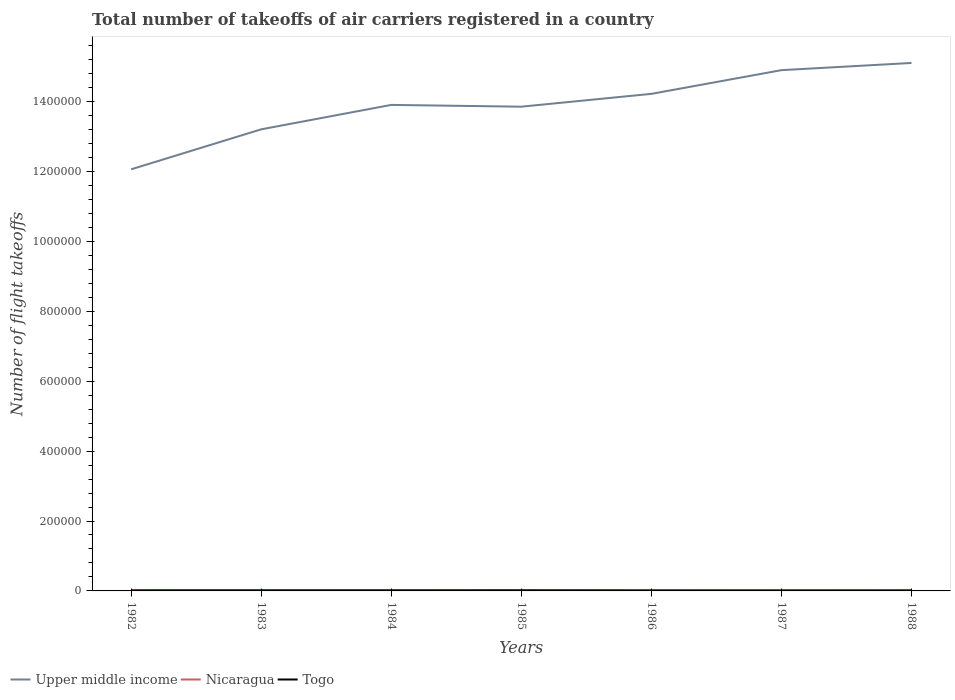How many different coloured lines are there?
Ensure brevity in your answer.  3. Does the line corresponding to Nicaragua intersect with the line corresponding to Togo?
Your response must be concise. No. Is the number of lines equal to the number of legend labels?
Your answer should be compact. Yes. Across all years, what is the maximum total number of flight takeoffs in Togo?
Provide a short and direct response. 1000. What is the total total number of flight takeoffs in Upper middle income in the graph?
Make the answer very short. -1.04e+05. What is the difference between the highest and the second highest total number of flight takeoffs in Upper middle income?
Offer a very short reply. 3.04e+05. How many lines are there?
Make the answer very short. 3. What is the difference between two consecutive major ticks on the Y-axis?
Make the answer very short. 2.00e+05. Are the values on the major ticks of Y-axis written in scientific E-notation?
Your response must be concise. No. How many legend labels are there?
Your answer should be very brief. 3. What is the title of the graph?
Your answer should be very brief. Total number of takeoffs of air carriers registered in a country. What is the label or title of the X-axis?
Make the answer very short. Years. What is the label or title of the Y-axis?
Give a very brief answer. Number of flight takeoffs. What is the Number of flight takeoffs of Upper middle income in 1982?
Provide a succinct answer. 1.21e+06. What is the Number of flight takeoffs in Nicaragua in 1982?
Ensure brevity in your answer.  1800. What is the Number of flight takeoffs in Togo in 1982?
Offer a very short reply. 1400. What is the Number of flight takeoffs in Upper middle income in 1983?
Your answer should be very brief. 1.32e+06. What is the Number of flight takeoffs in Nicaragua in 1983?
Ensure brevity in your answer.  1900. What is the Number of flight takeoffs of Togo in 1983?
Provide a succinct answer. 1400. What is the Number of flight takeoffs in Upper middle income in 1984?
Ensure brevity in your answer.  1.39e+06. What is the Number of flight takeoffs in Nicaragua in 1984?
Provide a succinct answer. 2200. What is the Number of flight takeoffs of Togo in 1984?
Your response must be concise. 1300. What is the Number of flight takeoffs of Upper middle income in 1985?
Provide a succinct answer. 1.39e+06. What is the Number of flight takeoffs of Nicaragua in 1985?
Provide a succinct answer. 2300. What is the Number of flight takeoffs in Togo in 1985?
Provide a succinct answer. 1400. What is the Number of flight takeoffs of Upper middle income in 1986?
Make the answer very short. 1.42e+06. What is the Number of flight takeoffs of Togo in 1986?
Offer a terse response. 1100. What is the Number of flight takeoffs in Upper middle income in 1987?
Your answer should be compact. 1.49e+06. What is the Number of flight takeoffs in Upper middle income in 1988?
Make the answer very short. 1.51e+06. What is the Number of flight takeoffs of Togo in 1988?
Your response must be concise. 1100. Across all years, what is the maximum Number of flight takeoffs of Upper middle income?
Offer a terse response. 1.51e+06. Across all years, what is the maximum Number of flight takeoffs in Nicaragua?
Your answer should be very brief. 2300. Across all years, what is the maximum Number of flight takeoffs in Togo?
Ensure brevity in your answer.  1400. Across all years, what is the minimum Number of flight takeoffs in Upper middle income?
Offer a terse response. 1.21e+06. Across all years, what is the minimum Number of flight takeoffs in Nicaragua?
Your answer should be very brief. 1800. Across all years, what is the minimum Number of flight takeoffs of Togo?
Provide a succinct answer. 1000. What is the total Number of flight takeoffs of Upper middle income in the graph?
Your response must be concise. 9.73e+06. What is the total Number of flight takeoffs of Nicaragua in the graph?
Provide a short and direct response. 1.42e+04. What is the total Number of flight takeoffs of Togo in the graph?
Ensure brevity in your answer.  8700. What is the difference between the Number of flight takeoffs of Upper middle income in 1982 and that in 1983?
Offer a terse response. -1.14e+05. What is the difference between the Number of flight takeoffs in Nicaragua in 1982 and that in 1983?
Your answer should be very brief. -100. What is the difference between the Number of flight takeoffs of Upper middle income in 1982 and that in 1984?
Ensure brevity in your answer.  -1.84e+05. What is the difference between the Number of flight takeoffs of Nicaragua in 1982 and that in 1984?
Your answer should be very brief. -400. What is the difference between the Number of flight takeoffs of Togo in 1982 and that in 1984?
Provide a short and direct response. 100. What is the difference between the Number of flight takeoffs in Upper middle income in 1982 and that in 1985?
Provide a short and direct response. -1.79e+05. What is the difference between the Number of flight takeoffs of Nicaragua in 1982 and that in 1985?
Your answer should be compact. -500. What is the difference between the Number of flight takeoffs in Upper middle income in 1982 and that in 1986?
Give a very brief answer. -2.16e+05. What is the difference between the Number of flight takeoffs of Nicaragua in 1982 and that in 1986?
Your answer should be compact. -200. What is the difference between the Number of flight takeoffs of Togo in 1982 and that in 1986?
Make the answer very short. 300. What is the difference between the Number of flight takeoffs of Upper middle income in 1982 and that in 1987?
Keep it short and to the point. -2.84e+05. What is the difference between the Number of flight takeoffs in Nicaragua in 1982 and that in 1987?
Offer a very short reply. -200. What is the difference between the Number of flight takeoffs of Togo in 1982 and that in 1987?
Ensure brevity in your answer.  400. What is the difference between the Number of flight takeoffs of Upper middle income in 1982 and that in 1988?
Your answer should be very brief. -3.04e+05. What is the difference between the Number of flight takeoffs of Nicaragua in 1982 and that in 1988?
Offer a very short reply. -200. What is the difference between the Number of flight takeoffs in Togo in 1982 and that in 1988?
Make the answer very short. 300. What is the difference between the Number of flight takeoffs in Upper middle income in 1983 and that in 1984?
Your response must be concise. -6.99e+04. What is the difference between the Number of flight takeoffs of Nicaragua in 1983 and that in 1984?
Make the answer very short. -300. What is the difference between the Number of flight takeoffs in Togo in 1983 and that in 1984?
Make the answer very short. 100. What is the difference between the Number of flight takeoffs in Upper middle income in 1983 and that in 1985?
Your answer should be very brief. -6.48e+04. What is the difference between the Number of flight takeoffs of Nicaragua in 1983 and that in 1985?
Keep it short and to the point. -400. What is the difference between the Number of flight takeoffs of Upper middle income in 1983 and that in 1986?
Keep it short and to the point. -1.02e+05. What is the difference between the Number of flight takeoffs of Nicaragua in 1983 and that in 1986?
Your response must be concise. -100. What is the difference between the Number of flight takeoffs of Togo in 1983 and that in 1986?
Offer a very short reply. 300. What is the difference between the Number of flight takeoffs of Upper middle income in 1983 and that in 1987?
Provide a succinct answer. -1.69e+05. What is the difference between the Number of flight takeoffs of Nicaragua in 1983 and that in 1987?
Keep it short and to the point. -100. What is the difference between the Number of flight takeoffs of Upper middle income in 1983 and that in 1988?
Offer a very short reply. -1.90e+05. What is the difference between the Number of flight takeoffs in Nicaragua in 1983 and that in 1988?
Keep it short and to the point. -100. What is the difference between the Number of flight takeoffs in Togo in 1983 and that in 1988?
Offer a very short reply. 300. What is the difference between the Number of flight takeoffs of Upper middle income in 1984 and that in 1985?
Your answer should be compact. 5100. What is the difference between the Number of flight takeoffs of Nicaragua in 1984 and that in 1985?
Make the answer very short. -100. What is the difference between the Number of flight takeoffs of Togo in 1984 and that in 1985?
Provide a succinct answer. -100. What is the difference between the Number of flight takeoffs in Upper middle income in 1984 and that in 1986?
Your answer should be very brief. -3.16e+04. What is the difference between the Number of flight takeoffs in Upper middle income in 1984 and that in 1987?
Offer a very short reply. -9.94e+04. What is the difference between the Number of flight takeoffs in Togo in 1984 and that in 1987?
Make the answer very short. 300. What is the difference between the Number of flight takeoffs of Upper middle income in 1984 and that in 1988?
Give a very brief answer. -1.20e+05. What is the difference between the Number of flight takeoffs of Togo in 1984 and that in 1988?
Your answer should be very brief. 200. What is the difference between the Number of flight takeoffs of Upper middle income in 1985 and that in 1986?
Your response must be concise. -3.67e+04. What is the difference between the Number of flight takeoffs of Nicaragua in 1985 and that in 1986?
Offer a terse response. 300. What is the difference between the Number of flight takeoffs in Togo in 1985 and that in 1986?
Your answer should be very brief. 300. What is the difference between the Number of flight takeoffs in Upper middle income in 1985 and that in 1987?
Your answer should be very brief. -1.04e+05. What is the difference between the Number of flight takeoffs of Nicaragua in 1985 and that in 1987?
Keep it short and to the point. 300. What is the difference between the Number of flight takeoffs of Upper middle income in 1985 and that in 1988?
Make the answer very short. -1.25e+05. What is the difference between the Number of flight takeoffs in Nicaragua in 1985 and that in 1988?
Offer a very short reply. 300. What is the difference between the Number of flight takeoffs of Togo in 1985 and that in 1988?
Your response must be concise. 300. What is the difference between the Number of flight takeoffs in Upper middle income in 1986 and that in 1987?
Offer a terse response. -6.78e+04. What is the difference between the Number of flight takeoffs of Nicaragua in 1986 and that in 1987?
Make the answer very short. 0. What is the difference between the Number of flight takeoffs of Upper middle income in 1986 and that in 1988?
Offer a terse response. -8.84e+04. What is the difference between the Number of flight takeoffs in Togo in 1986 and that in 1988?
Give a very brief answer. 0. What is the difference between the Number of flight takeoffs of Upper middle income in 1987 and that in 1988?
Give a very brief answer. -2.06e+04. What is the difference between the Number of flight takeoffs of Togo in 1987 and that in 1988?
Give a very brief answer. -100. What is the difference between the Number of flight takeoffs of Upper middle income in 1982 and the Number of flight takeoffs of Nicaragua in 1983?
Ensure brevity in your answer.  1.20e+06. What is the difference between the Number of flight takeoffs in Upper middle income in 1982 and the Number of flight takeoffs in Togo in 1983?
Give a very brief answer. 1.20e+06. What is the difference between the Number of flight takeoffs of Nicaragua in 1982 and the Number of flight takeoffs of Togo in 1983?
Ensure brevity in your answer.  400. What is the difference between the Number of flight takeoffs in Upper middle income in 1982 and the Number of flight takeoffs in Nicaragua in 1984?
Ensure brevity in your answer.  1.20e+06. What is the difference between the Number of flight takeoffs in Upper middle income in 1982 and the Number of flight takeoffs in Togo in 1984?
Make the answer very short. 1.20e+06. What is the difference between the Number of flight takeoffs of Upper middle income in 1982 and the Number of flight takeoffs of Nicaragua in 1985?
Offer a terse response. 1.20e+06. What is the difference between the Number of flight takeoffs of Upper middle income in 1982 and the Number of flight takeoffs of Togo in 1985?
Provide a short and direct response. 1.20e+06. What is the difference between the Number of flight takeoffs in Nicaragua in 1982 and the Number of flight takeoffs in Togo in 1985?
Provide a short and direct response. 400. What is the difference between the Number of flight takeoffs of Upper middle income in 1982 and the Number of flight takeoffs of Nicaragua in 1986?
Your answer should be compact. 1.20e+06. What is the difference between the Number of flight takeoffs in Upper middle income in 1982 and the Number of flight takeoffs in Togo in 1986?
Provide a short and direct response. 1.21e+06. What is the difference between the Number of flight takeoffs in Nicaragua in 1982 and the Number of flight takeoffs in Togo in 1986?
Give a very brief answer. 700. What is the difference between the Number of flight takeoffs of Upper middle income in 1982 and the Number of flight takeoffs of Nicaragua in 1987?
Give a very brief answer. 1.20e+06. What is the difference between the Number of flight takeoffs of Upper middle income in 1982 and the Number of flight takeoffs of Togo in 1987?
Your answer should be very brief. 1.21e+06. What is the difference between the Number of flight takeoffs of Nicaragua in 1982 and the Number of flight takeoffs of Togo in 1987?
Make the answer very short. 800. What is the difference between the Number of flight takeoffs in Upper middle income in 1982 and the Number of flight takeoffs in Nicaragua in 1988?
Keep it short and to the point. 1.20e+06. What is the difference between the Number of flight takeoffs in Upper middle income in 1982 and the Number of flight takeoffs in Togo in 1988?
Keep it short and to the point. 1.21e+06. What is the difference between the Number of flight takeoffs of Nicaragua in 1982 and the Number of flight takeoffs of Togo in 1988?
Give a very brief answer. 700. What is the difference between the Number of flight takeoffs in Upper middle income in 1983 and the Number of flight takeoffs in Nicaragua in 1984?
Provide a succinct answer. 1.32e+06. What is the difference between the Number of flight takeoffs of Upper middle income in 1983 and the Number of flight takeoffs of Togo in 1984?
Provide a short and direct response. 1.32e+06. What is the difference between the Number of flight takeoffs of Nicaragua in 1983 and the Number of flight takeoffs of Togo in 1984?
Give a very brief answer. 600. What is the difference between the Number of flight takeoffs of Upper middle income in 1983 and the Number of flight takeoffs of Nicaragua in 1985?
Your answer should be very brief. 1.32e+06. What is the difference between the Number of flight takeoffs of Upper middle income in 1983 and the Number of flight takeoffs of Togo in 1985?
Ensure brevity in your answer.  1.32e+06. What is the difference between the Number of flight takeoffs in Nicaragua in 1983 and the Number of flight takeoffs in Togo in 1985?
Ensure brevity in your answer.  500. What is the difference between the Number of flight takeoffs in Upper middle income in 1983 and the Number of flight takeoffs in Nicaragua in 1986?
Give a very brief answer. 1.32e+06. What is the difference between the Number of flight takeoffs in Upper middle income in 1983 and the Number of flight takeoffs in Togo in 1986?
Provide a short and direct response. 1.32e+06. What is the difference between the Number of flight takeoffs of Nicaragua in 1983 and the Number of flight takeoffs of Togo in 1986?
Offer a very short reply. 800. What is the difference between the Number of flight takeoffs in Upper middle income in 1983 and the Number of flight takeoffs in Nicaragua in 1987?
Ensure brevity in your answer.  1.32e+06. What is the difference between the Number of flight takeoffs of Upper middle income in 1983 and the Number of flight takeoffs of Togo in 1987?
Offer a terse response. 1.32e+06. What is the difference between the Number of flight takeoffs of Nicaragua in 1983 and the Number of flight takeoffs of Togo in 1987?
Your answer should be very brief. 900. What is the difference between the Number of flight takeoffs in Upper middle income in 1983 and the Number of flight takeoffs in Nicaragua in 1988?
Provide a short and direct response. 1.32e+06. What is the difference between the Number of flight takeoffs of Upper middle income in 1983 and the Number of flight takeoffs of Togo in 1988?
Provide a succinct answer. 1.32e+06. What is the difference between the Number of flight takeoffs in Nicaragua in 1983 and the Number of flight takeoffs in Togo in 1988?
Make the answer very short. 800. What is the difference between the Number of flight takeoffs of Upper middle income in 1984 and the Number of flight takeoffs of Nicaragua in 1985?
Make the answer very short. 1.39e+06. What is the difference between the Number of flight takeoffs of Upper middle income in 1984 and the Number of flight takeoffs of Togo in 1985?
Ensure brevity in your answer.  1.39e+06. What is the difference between the Number of flight takeoffs of Nicaragua in 1984 and the Number of flight takeoffs of Togo in 1985?
Offer a terse response. 800. What is the difference between the Number of flight takeoffs in Upper middle income in 1984 and the Number of flight takeoffs in Nicaragua in 1986?
Your answer should be very brief. 1.39e+06. What is the difference between the Number of flight takeoffs of Upper middle income in 1984 and the Number of flight takeoffs of Togo in 1986?
Your response must be concise. 1.39e+06. What is the difference between the Number of flight takeoffs in Nicaragua in 1984 and the Number of flight takeoffs in Togo in 1986?
Offer a terse response. 1100. What is the difference between the Number of flight takeoffs of Upper middle income in 1984 and the Number of flight takeoffs of Nicaragua in 1987?
Offer a terse response. 1.39e+06. What is the difference between the Number of flight takeoffs in Upper middle income in 1984 and the Number of flight takeoffs in Togo in 1987?
Give a very brief answer. 1.39e+06. What is the difference between the Number of flight takeoffs in Nicaragua in 1984 and the Number of flight takeoffs in Togo in 1987?
Make the answer very short. 1200. What is the difference between the Number of flight takeoffs in Upper middle income in 1984 and the Number of flight takeoffs in Nicaragua in 1988?
Give a very brief answer. 1.39e+06. What is the difference between the Number of flight takeoffs in Upper middle income in 1984 and the Number of flight takeoffs in Togo in 1988?
Your answer should be compact. 1.39e+06. What is the difference between the Number of flight takeoffs of Nicaragua in 1984 and the Number of flight takeoffs of Togo in 1988?
Offer a terse response. 1100. What is the difference between the Number of flight takeoffs of Upper middle income in 1985 and the Number of flight takeoffs of Nicaragua in 1986?
Provide a short and direct response. 1.38e+06. What is the difference between the Number of flight takeoffs of Upper middle income in 1985 and the Number of flight takeoffs of Togo in 1986?
Make the answer very short. 1.38e+06. What is the difference between the Number of flight takeoffs in Nicaragua in 1985 and the Number of flight takeoffs in Togo in 1986?
Offer a terse response. 1200. What is the difference between the Number of flight takeoffs of Upper middle income in 1985 and the Number of flight takeoffs of Nicaragua in 1987?
Your answer should be compact. 1.38e+06. What is the difference between the Number of flight takeoffs in Upper middle income in 1985 and the Number of flight takeoffs in Togo in 1987?
Give a very brief answer. 1.38e+06. What is the difference between the Number of flight takeoffs of Nicaragua in 1985 and the Number of flight takeoffs of Togo in 1987?
Provide a succinct answer. 1300. What is the difference between the Number of flight takeoffs of Upper middle income in 1985 and the Number of flight takeoffs of Nicaragua in 1988?
Your response must be concise. 1.38e+06. What is the difference between the Number of flight takeoffs in Upper middle income in 1985 and the Number of flight takeoffs in Togo in 1988?
Ensure brevity in your answer.  1.38e+06. What is the difference between the Number of flight takeoffs of Nicaragua in 1985 and the Number of flight takeoffs of Togo in 1988?
Offer a terse response. 1200. What is the difference between the Number of flight takeoffs of Upper middle income in 1986 and the Number of flight takeoffs of Nicaragua in 1987?
Provide a succinct answer. 1.42e+06. What is the difference between the Number of flight takeoffs of Upper middle income in 1986 and the Number of flight takeoffs of Togo in 1987?
Your answer should be very brief. 1.42e+06. What is the difference between the Number of flight takeoffs in Upper middle income in 1986 and the Number of flight takeoffs in Nicaragua in 1988?
Offer a terse response. 1.42e+06. What is the difference between the Number of flight takeoffs of Upper middle income in 1986 and the Number of flight takeoffs of Togo in 1988?
Give a very brief answer. 1.42e+06. What is the difference between the Number of flight takeoffs in Nicaragua in 1986 and the Number of flight takeoffs in Togo in 1988?
Ensure brevity in your answer.  900. What is the difference between the Number of flight takeoffs of Upper middle income in 1987 and the Number of flight takeoffs of Nicaragua in 1988?
Ensure brevity in your answer.  1.49e+06. What is the difference between the Number of flight takeoffs in Upper middle income in 1987 and the Number of flight takeoffs in Togo in 1988?
Provide a short and direct response. 1.49e+06. What is the difference between the Number of flight takeoffs of Nicaragua in 1987 and the Number of flight takeoffs of Togo in 1988?
Your answer should be very brief. 900. What is the average Number of flight takeoffs in Upper middle income per year?
Offer a very short reply. 1.39e+06. What is the average Number of flight takeoffs of Nicaragua per year?
Provide a short and direct response. 2028.57. What is the average Number of flight takeoffs of Togo per year?
Your answer should be compact. 1242.86. In the year 1982, what is the difference between the Number of flight takeoffs of Upper middle income and Number of flight takeoffs of Nicaragua?
Your response must be concise. 1.20e+06. In the year 1982, what is the difference between the Number of flight takeoffs of Upper middle income and Number of flight takeoffs of Togo?
Make the answer very short. 1.20e+06. In the year 1982, what is the difference between the Number of flight takeoffs of Nicaragua and Number of flight takeoffs of Togo?
Your answer should be very brief. 400. In the year 1983, what is the difference between the Number of flight takeoffs in Upper middle income and Number of flight takeoffs in Nicaragua?
Provide a short and direct response. 1.32e+06. In the year 1983, what is the difference between the Number of flight takeoffs of Upper middle income and Number of flight takeoffs of Togo?
Offer a terse response. 1.32e+06. In the year 1983, what is the difference between the Number of flight takeoffs of Nicaragua and Number of flight takeoffs of Togo?
Offer a very short reply. 500. In the year 1984, what is the difference between the Number of flight takeoffs of Upper middle income and Number of flight takeoffs of Nicaragua?
Give a very brief answer. 1.39e+06. In the year 1984, what is the difference between the Number of flight takeoffs in Upper middle income and Number of flight takeoffs in Togo?
Offer a terse response. 1.39e+06. In the year 1984, what is the difference between the Number of flight takeoffs of Nicaragua and Number of flight takeoffs of Togo?
Ensure brevity in your answer.  900. In the year 1985, what is the difference between the Number of flight takeoffs in Upper middle income and Number of flight takeoffs in Nicaragua?
Offer a very short reply. 1.38e+06. In the year 1985, what is the difference between the Number of flight takeoffs in Upper middle income and Number of flight takeoffs in Togo?
Your answer should be compact. 1.38e+06. In the year 1985, what is the difference between the Number of flight takeoffs of Nicaragua and Number of flight takeoffs of Togo?
Give a very brief answer. 900. In the year 1986, what is the difference between the Number of flight takeoffs of Upper middle income and Number of flight takeoffs of Nicaragua?
Your answer should be compact. 1.42e+06. In the year 1986, what is the difference between the Number of flight takeoffs of Upper middle income and Number of flight takeoffs of Togo?
Give a very brief answer. 1.42e+06. In the year 1986, what is the difference between the Number of flight takeoffs in Nicaragua and Number of flight takeoffs in Togo?
Make the answer very short. 900. In the year 1987, what is the difference between the Number of flight takeoffs of Upper middle income and Number of flight takeoffs of Nicaragua?
Provide a short and direct response. 1.49e+06. In the year 1987, what is the difference between the Number of flight takeoffs in Upper middle income and Number of flight takeoffs in Togo?
Ensure brevity in your answer.  1.49e+06. In the year 1988, what is the difference between the Number of flight takeoffs in Upper middle income and Number of flight takeoffs in Nicaragua?
Provide a short and direct response. 1.51e+06. In the year 1988, what is the difference between the Number of flight takeoffs of Upper middle income and Number of flight takeoffs of Togo?
Give a very brief answer. 1.51e+06. In the year 1988, what is the difference between the Number of flight takeoffs of Nicaragua and Number of flight takeoffs of Togo?
Your response must be concise. 900. What is the ratio of the Number of flight takeoffs of Upper middle income in 1982 to that in 1983?
Make the answer very short. 0.91. What is the ratio of the Number of flight takeoffs of Togo in 1982 to that in 1983?
Offer a terse response. 1. What is the ratio of the Number of flight takeoffs of Upper middle income in 1982 to that in 1984?
Your answer should be compact. 0.87. What is the ratio of the Number of flight takeoffs in Nicaragua in 1982 to that in 1984?
Your answer should be very brief. 0.82. What is the ratio of the Number of flight takeoffs of Togo in 1982 to that in 1984?
Keep it short and to the point. 1.08. What is the ratio of the Number of flight takeoffs of Upper middle income in 1982 to that in 1985?
Your response must be concise. 0.87. What is the ratio of the Number of flight takeoffs of Nicaragua in 1982 to that in 1985?
Your response must be concise. 0.78. What is the ratio of the Number of flight takeoffs of Togo in 1982 to that in 1985?
Offer a terse response. 1. What is the ratio of the Number of flight takeoffs in Upper middle income in 1982 to that in 1986?
Keep it short and to the point. 0.85. What is the ratio of the Number of flight takeoffs of Nicaragua in 1982 to that in 1986?
Make the answer very short. 0.9. What is the ratio of the Number of flight takeoffs of Togo in 1982 to that in 1986?
Your answer should be compact. 1.27. What is the ratio of the Number of flight takeoffs in Upper middle income in 1982 to that in 1987?
Keep it short and to the point. 0.81. What is the ratio of the Number of flight takeoffs in Nicaragua in 1982 to that in 1987?
Your answer should be very brief. 0.9. What is the ratio of the Number of flight takeoffs in Togo in 1982 to that in 1987?
Keep it short and to the point. 1.4. What is the ratio of the Number of flight takeoffs of Upper middle income in 1982 to that in 1988?
Your answer should be compact. 0.8. What is the ratio of the Number of flight takeoffs in Nicaragua in 1982 to that in 1988?
Provide a short and direct response. 0.9. What is the ratio of the Number of flight takeoffs in Togo in 1982 to that in 1988?
Make the answer very short. 1.27. What is the ratio of the Number of flight takeoffs of Upper middle income in 1983 to that in 1984?
Offer a terse response. 0.95. What is the ratio of the Number of flight takeoffs in Nicaragua in 1983 to that in 1984?
Your answer should be compact. 0.86. What is the ratio of the Number of flight takeoffs in Upper middle income in 1983 to that in 1985?
Offer a terse response. 0.95. What is the ratio of the Number of flight takeoffs in Nicaragua in 1983 to that in 1985?
Your answer should be very brief. 0.83. What is the ratio of the Number of flight takeoffs of Togo in 1983 to that in 1985?
Make the answer very short. 1. What is the ratio of the Number of flight takeoffs in Togo in 1983 to that in 1986?
Keep it short and to the point. 1.27. What is the ratio of the Number of flight takeoffs in Upper middle income in 1983 to that in 1987?
Keep it short and to the point. 0.89. What is the ratio of the Number of flight takeoffs of Upper middle income in 1983 to that in 1988?
Your response must be concise. 0.87. What is the ratio of the Number of flight takeoffs in Togo in 1983 to that in 1988?
Provide a succinct answer. 1.27. What is the ratio of the Number of flight takeoffs of Upper middle income in 1984 to that in 1985?
Offer a terse response. 1. What is the ratio of the Number of flight takeoffs of Nicaragua in 1984 to that in 1985?
Provide a short and direct response. 0.96. What is the ratio of the Number of flight takeoffs of Upper middle income in 1984 to that in 1986?
Offer a terse response. 0.98. What is the ratio of the Number of flight takeoffs of Nicaragua in 1984 to that in 1986?
Make the answer very short. 1.1. What is the ratio of the Number of flight takeoffs of Togo in 1984 to that in 1986?
Provide a short and direct response. 1.18. What is the ratio of the Number of flight takeoffs of Upper middle income in 1984 to that in 1987?
Your answer should be very brief. 0.93. What is the ratio of the Number of flight takeoffs of Nicaragua in 1984 to that in 1987?
Your answer should be compact. 1.1. What is the ratio of the Number of flight takeoffs in Togo in 1984 to that in 1987?
Your answer should be very brief. 1.3. What is the ratio of the Number of flight takeoffs of Upper middle income in 1984 to that in 1988?
Give a very brief answer. 0.92. What is the ratio of the Number of flight takeoffs in Nicaragua in 1984 to that in 1988?
Ensure brevity in your answer.  1.1. What is the ratio of the Number of flight takeoffs in Togo in 1984 to that in 1988?
Your answer should be compact. 1.18. What is the ratio of the Number of flight takeoffs in Upper middle income in 1985 to that in 1986?
Your response must be concise. 0.97. What is the ratio of the Number of flight takeoffs in Nicaragua in 1985 to that in 1986?
Your answer should be very brief. 1.15. What is the ratio of the Number of flight takeoffs of Togo in 1985 to that in 1986?
Keep it short and to the point. 1.27. What is the ratio of the Number of flight takeoffs of Upper middle income in 1985 to that in 1987?
Your answer should be very brief. 0.93. What is the ratio of the Number of flight takeoffs in Nicaragua in 1985 to that in 1987?
Provide a short and direct response. 1.15. What is the ratio of the Number of flight takeoffs in Togo in 1985 to that in 1987?
Your response must be concise. 1.4. What is the ratio of the Number of flight takeoffs in Upper middle income in 1985 to that in 1988?
Offer a terse response. 0.92. What is the ratio of the Number of flight takeoffs of Nicaragua in 1985 to that in 1988?
Offer a very short reply. 1.15. What is the ratio of the Number of flight takeoffs in Togo in 1985 to that in 1988?
Ensure brevity in your answer.  1.27. What is the ratio of the Number of flight takeoffs of Upper middle income in 1986 to that in 1987?
Ensure brevity in your answer.  0.95. What is the ratio of the Number of flight takeoffs of Upper middle income in 1986 to that in 1988?
Your response must be concise. 0.94. What is the ratio of the Number of flight takeoffs of Nicaragua in 1986 to that in 1988?
Provide a succinct answer. 1. What is the ratio of the Number of flight takeoffs in Upper middle income in 1987 to that in 1988?
Provide a short and direct response. 0.99. What is the ratio of the Number of flight takeoffs of Nicaragua in 1987 to that in 1988?
Keep it short and to the point. 1. What is the difference between the highest and the second highest Number of flight takeoffs of Upper middle income?
Offer a terse response. 2.06e+04. What is the difference between the highest and the second highest Number of flight takeoffs of Nicaragua?
Provide a succinct answer. 100. What is the difference between the highest and the second highest Number of flight takeoffs in Togo?
Provide a short and direct response. 0. What is the difference between the highest and the lowest Number of flight takeoffs of Upper middle income?
Make the answer very short. 3.04e+05. 